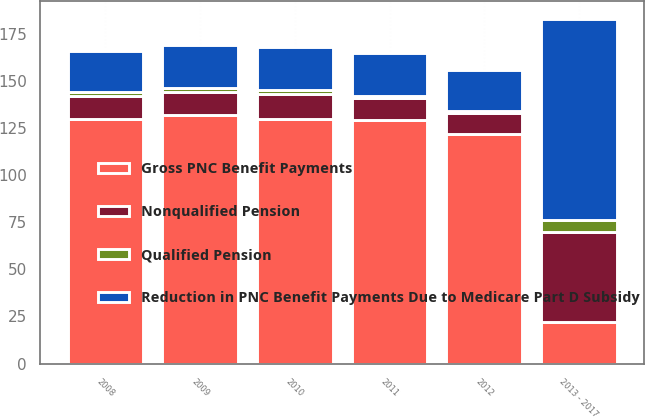Convert chart to OTSL. <chart><loc_0><loc_0><loc_500><loc_500><stacked_bar_chart><ecel><fcel>2008<fcel>2009<fcel>2010<fcel>2011<fcel>2012<fcel>2013 - 2017<nl><fcel>Gross PNC Benefit Payments<fcel>130<fcel>132<fcel>130<fcel>129<fcel>122<fcel>22<nl><fcel>Nonqualified Pension<fcel>12<fcel>12<fcel>13<fcel>12<fcel>11<fcel>48<nl><fcel>Reduction in PNC Benefit Payments Due to Medicare Part D Subsidy<fcel>22<fcel>23<fcel>23<fcel>23<fcel>22<fcel>107<nl><fcel>Qualified Pension<fcel>2<fcel>2<fcel>2<fcel>1<fcel>1<fcel>6<nl></chart> 